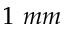<formula> <loc_0><loc_0><loc_500><loc_500>1 \ m m</formula> 